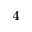<formula> <loc_0><loc_0><loc_500><loc_500>_ { 4 }</formula> 